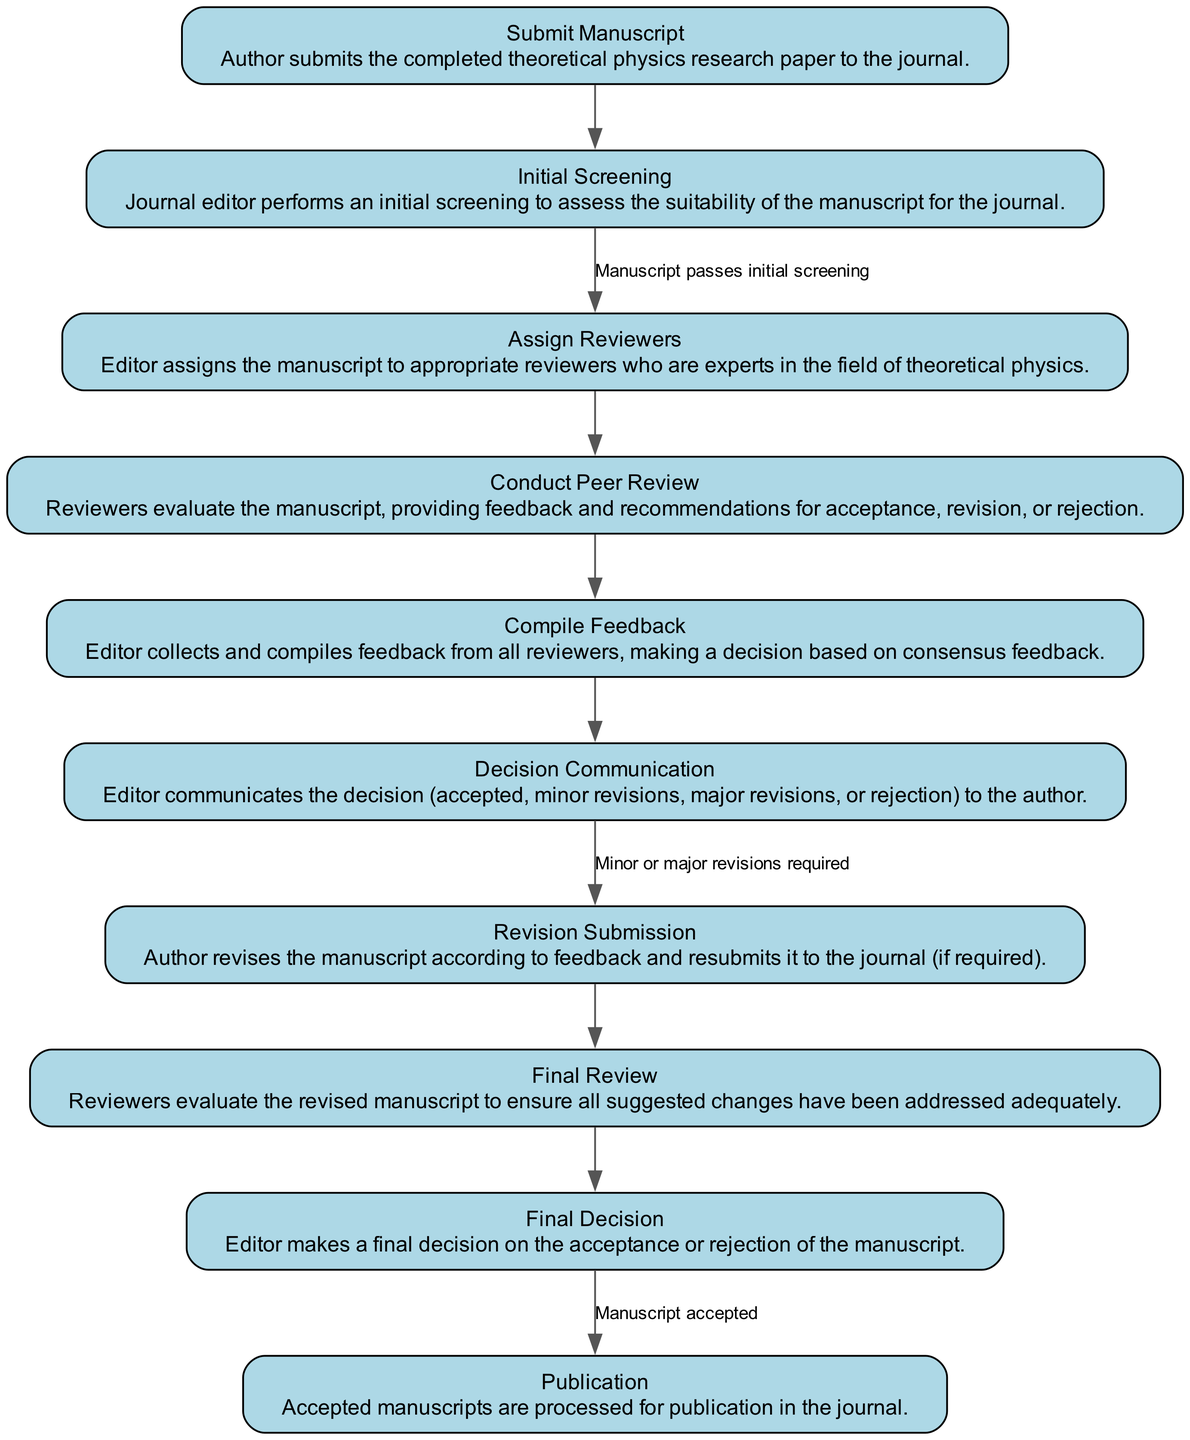What is the first activity in the peer-review process? The first activity is "Submit Manuscript." This is clearly indicated as the starting point of the diagram.
Answer: Submit Manuscript How many edges are there in the diagram? By counting the connections between nodes, there are a total of 9 edges representing transitions between activities.
Answer: 9 What decision outcomes can result from the "Decision Communication" activity? The decision outcomes specified in the diagram are "accepted," "minor revisions," "major revisions," or "rejection."
Answer: accepted, minor revisions, major revisions, rejection What must happen for the "Revision Submission" to occur? "Revision Submission" occurs when the author revises the manuscript according to feedback, which is a direct consequence of the decision communicated from the "Decision Communication" activity.
Answer: Minor or major revisions required What is the condition that leads from "Final Decision" to "Publication"? The condition leading to "Publication" is that the manuscript must be accepted. This is explicitly stated as a requirement in the transition.
Answer: Manuscript accepted How many total activities are present in the diagram? The diagram lists 10 distinct activities involved in the peer-review process of the theoretical physics research paper.
Answer: 10 Which activity follows "Conduct Peer Review"? The "Conduct Peer Review" activity directly transitions to "Compile Feedback," as indicated by the edge connecting these two nodes.
Answer: Compile Feedback What is required before "Final Review" can take place? Before "Final Review" can happen, the author must go through "Revision Submission" and present the revised manuscript for evaluation. This is a sequential step indicated in the diagram.
Answer: Revision Submission 